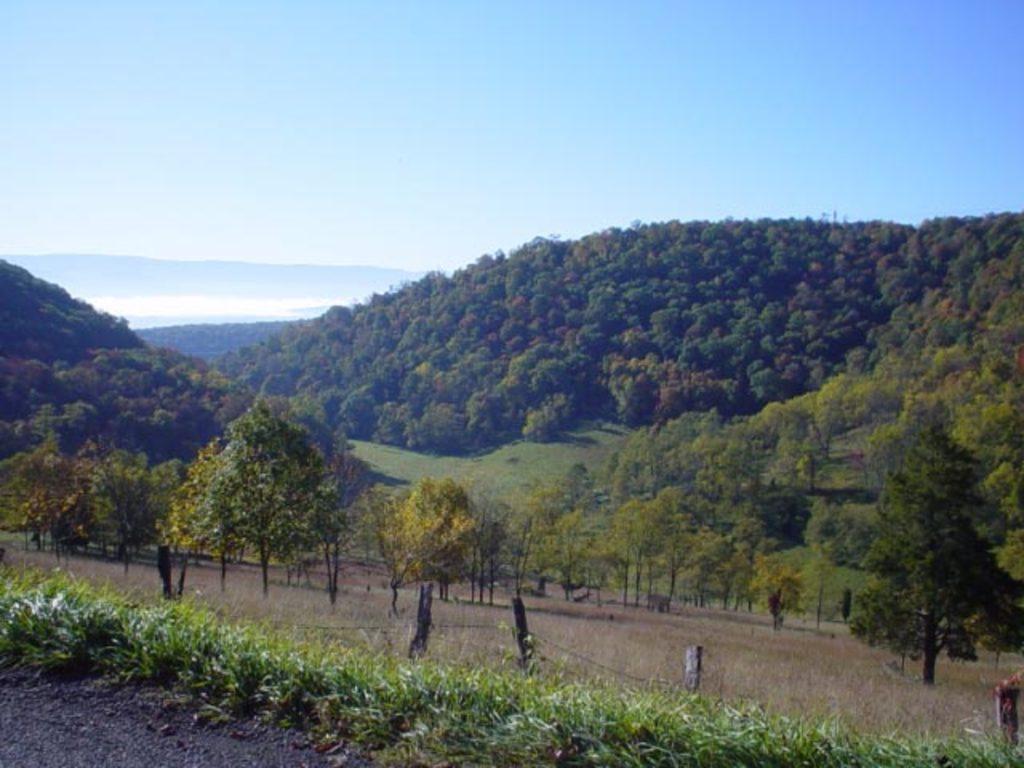How would you summarize this image in a sentence or two? In this image we can see trees, hills, plants, grass, fencing and sky. 